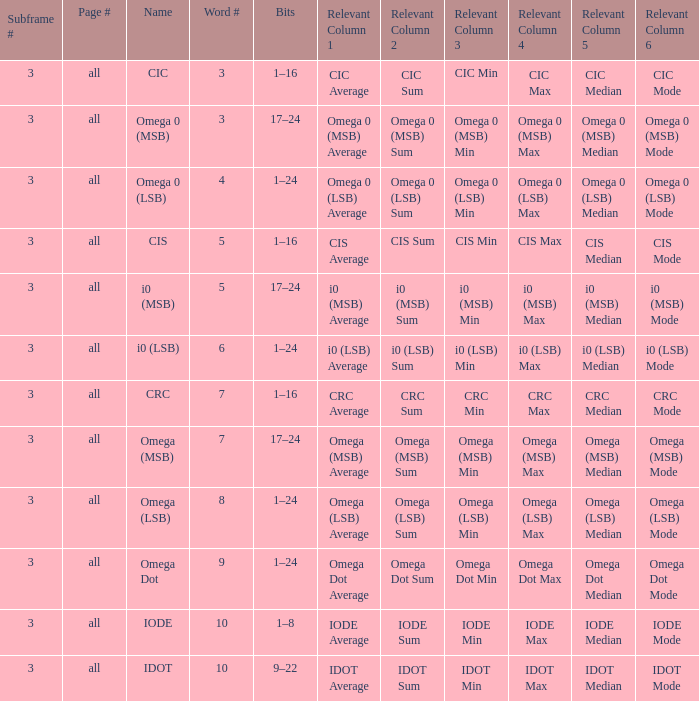What is the overall word count for subframes exceeding 3 in number? None. 